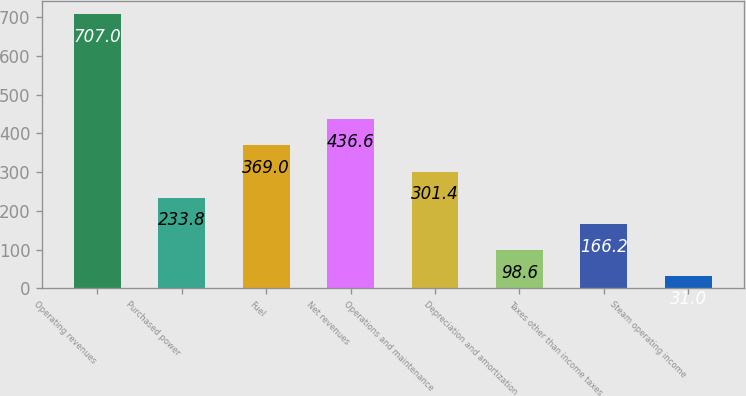Convert chart to OTSL. <chart><loc_0><loc_0><loc_500><loc_500><bar_chart><fcel>Operating revenues<fcel>Purchased power<fcel>Fuel<fcel>Net revenues<fcel>Operations and maintenance<fcel>Depreciation and amortization<fcel>Taxes other than income taxes<fcel>Steam operating income<nl><fcel>707<fcel>233.8<fcel>369<fcel>436.6<fcel>301.4<fcel>98.6<fcel>166.2<fcel>31<nl></chart> 